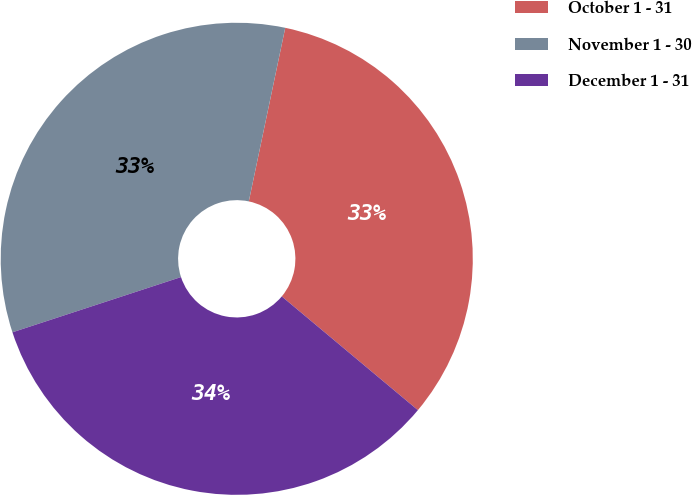Convert chart. <chart><loc_0><loc_0><loc_500><loc_500><pie_chart><fcel>October 1 - 31<fcel>November 1 - 30<fcel>December 1 - 31<nl><fcel>32.78%<fcel>33.33%<fcel>33.88%<nl></chart> 